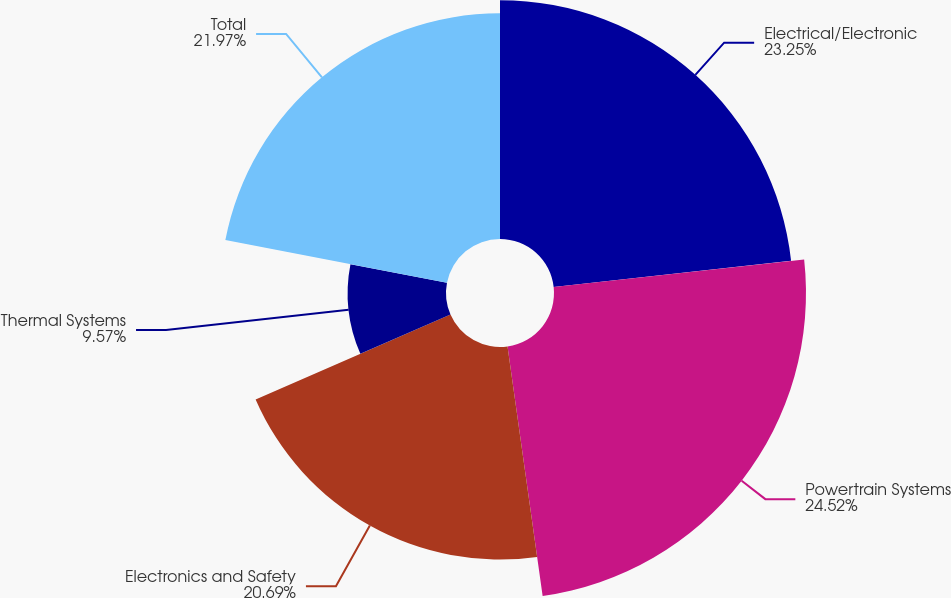Convert chart. <chart><loc_0><loc_0><loc_500><loc_500><pie_chart><fcel>Electrical/Electronic<fcel>Powertrain Systems<fcel>Electronics and Safety<fcel>Thermal Systems<fcel>Total<nl><fcel>23.25%<fcel>24.53%<fcel>20.69%<fcel>9.57%<fcel>21.97%<nl></chart> 